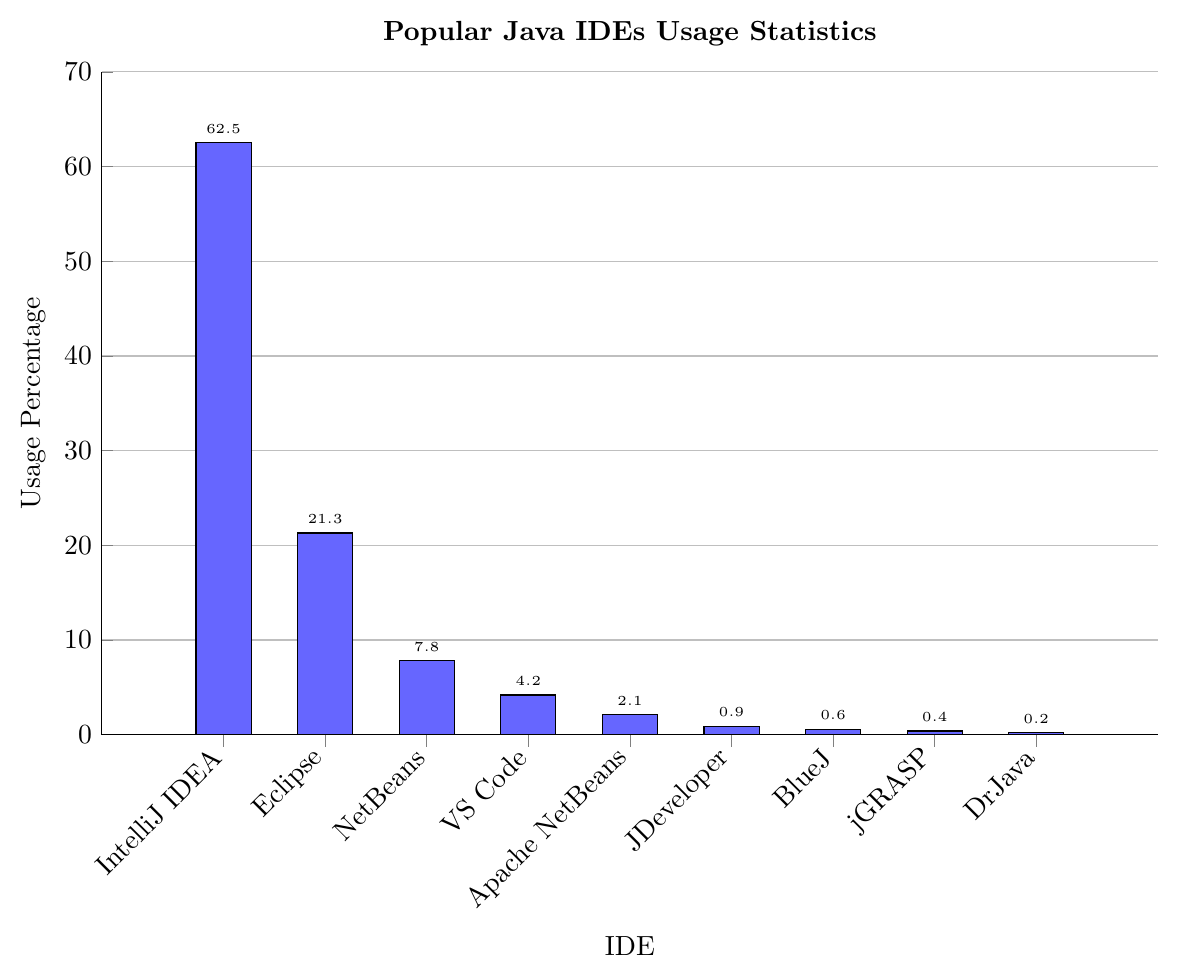Which IDE has the highest usage percentage? The bar representing IntelliJ IDEA is the tallest, corresponding to the highest usage percentage of 62.5%.
Answer: IntelliJ IDEA What is the combined usage percentage of Eclipse and NetBeans? The usage percentage of Eclipse is 21.3% and NetBeans is 7.8%. Adding them together gives 21.3 + 7.8 = 29.1%.
Answer: 29.1% Which IDE has the lowest usage percentage? The bar representing DrJava is the shortest, indicating the lowest usage percentage of 0.2%.
Answer: DrJava How much higher is IntelliJ IDEA's usage compared to Visual Studio Code? IntelliJ IDEA's usage is 62.5%, and Visual Studio Code's usage is 4.2%. The difference is 62.5 - 4.2 = 58.3%.
Answer: 58.3% What is the average usage percentage of JDeveloper, BlueJ, jGRASP, and DrJava? Sum the usage percentages first: 0.9% (JDeveloper) + 0.6% (BlueJ) + 0.4% (jGRASP) + 0.2% (DrJava) = 2.1%. There are 4 IDEs, so the average is 2.1 / 4 = 0.525%.
Answer: 0.525% Are there more IDEs with usage percentages above 5% or below 5%? IDEs above 5% are IntelliJ IDEA, Eclipse, and NetBeans. IDEs below 5% are Visual Studio Code, Apache NetBeans, JDeveloper, BlueJ, jGRASP, and DrJava. There are 3 IDEs over 5% and 6 IDEs below 5%.
Answer: Below 5% What is the usage percentage difference between the most popular and the least popular IDEs? The most popular IDE is IntelliJ IDEA with 62.5% and the least popular is DrJava with 0.2%. The difference is 62.5 - 0.2 = 62.3%.
Answer: 62.3% Which two adjacent IDEs in the list have the closest usage percentages? The closest usage percentages are between BlueJ (0.6%) and jGRASP (0.4%). The difference is 0.6 - 0.4 = 0.2%.
Answer: BlueJ and jGRASP What is the total usage percentage of all IDEs combined? Sum up all the usage percentages: 62.5 + 21.3 + 7.8 + 4.2 + 2.1 + 0.9 + 0.6 + 0.4 + 0.2 = 100%.
Answer: 100% How does the usage percentage of Apache NetBeans compare to JDeveloper? Apache NetBeans has a usage of 2.1% and JDeveloper has 0.9%. Apache NetBeans has a higher usage, with a difference of 2.1 - 0.9 = 1.2%.
Answer: Apache NetBeans is higher by 1.2% 